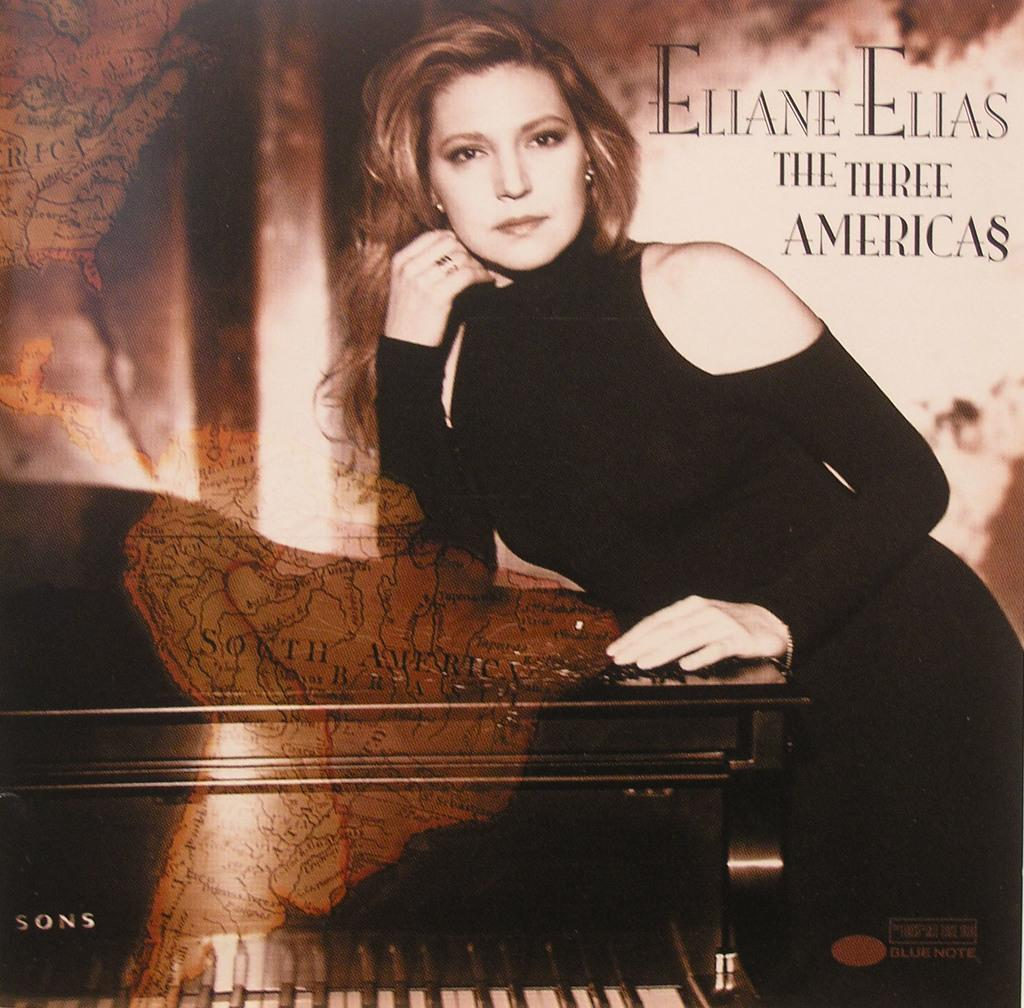What is the main subject of the image? The main subject of the image is a woman. What is the woman doing in the image? The woman is standing and smiling in the image. What is the woman touching in the image? The woman has her hands on a piano table in the image. What else can be seen in the image besides the woman? There is a poster present in the image. What type of pet can be seen sitting next to the woman in the image? There is no pet present in the image; it only features a woman, a piano table, and a poster. What place is depicted in the background of the image? There is no background or place depicted in the image; it focuses on the woman, the piano table, and the poster. 